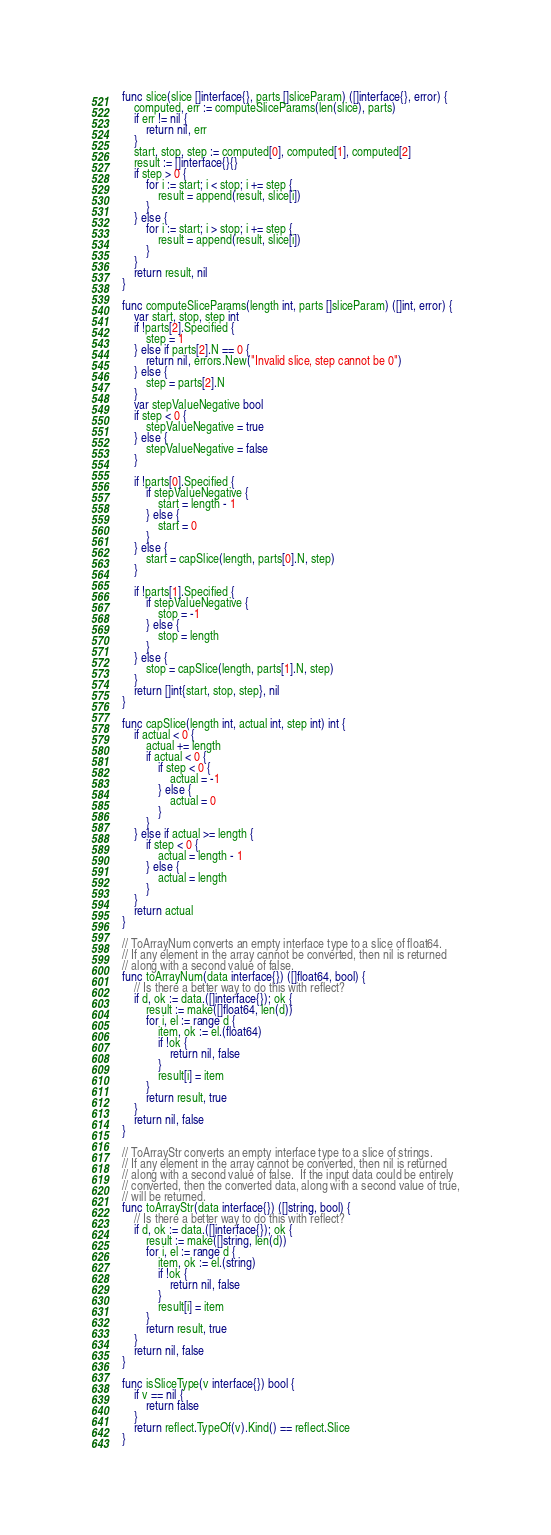<code> <loc_0><loc_0><loc_500><loc_500><_Go_>func slice(slice []interface{}, parts []sliceParam) ([]interface{}, error) {
	computed, err := computeSliceParams(len(slice), parts)
	if err != nil {
		return nil, err
	}
	start, stop, step := computed[0], computed[1], computed[2]
	result := []interface{}{}
	if step > 0 {
		for i := start; i < stop; i += step {
			result = append(result, slice[i])
		}
	} else {
		for i := start; i > stop; i += step {
			result = append(result, slice[i])
		}
	}
	return result, nil
}

func computeSliceParams(length int, parts []sliceParam) ([]int, error) {
	var start, stop, step int
	if !parts[2].Specified {
		step = 1
	} else if parts[2].N == 0 {
		return nil, errors.New("Invalid slice, step cannot be 0")
	} else {
		step = parts[2].N
	}
	var stepValueNegative bool
	if step < 0 {
		stepValueNegative = true
	} else {
		stepValueNegative = false
	}

	if !parts[0].Specified {
		if stepValueNegative {
			start = length - 1
		} else {
			start = 0
		}
	} else {
		start = capSlice(length, parts[0].N, step)
	}

	if !parts[1].Specified {
		if stepValueNegative {
			stop = -1
		} else {
			stop = length
		}
	} else {
		stop = capSlice(length, parts[1].N, step)
	}
	return []int{start, stop, step}, nil
}

func capSlice(length int, actual int, step int) int {
	if actual < 0 {
		actual += length
		if actual < 0 {
			if step < 0 {
				actual = -1
			} else {
				actual = 0
			}
		}
	} else if actual >= length {
		if step < 0 {
			actual = length - 1
		} else {
			actual = length
		}
	}
	return actual
}

// ToArrayNum converts an empty interface type to a slice of float64.
// If any element in the array cannot be converted, then nil is returned
// along with a second value of false.
func toArrayNum(data interface{}) ([]float64, bool) {
	// Is there a better way to do this with reflect?
	if d, ok := data.([]interface{}); ok {
		result := make([]float64, len(d))
		for i, el := range d {
			item, ok := el.(float64)
			if !ok {
				return nil, false
			}
			result[i] = item
		}
		return result, true
	}
	return nil, false
}

// ToArrayStr converts an empty interface type to a slice of strings.
// If any element in the array cannot be converted, then nil is returned
// along with a second value of false.  If the input data could be entirely
// converted, then the converted data, along with a second value of true,
// will be returned.
func toArrayStr(data interface{}) ([]string, bool) {
	// Is there a better way to do this with reflect?
	if d, ok := data.([]interface{}); ok {
		result := make([]string, len(d))
		for i, el := range d {
			item, ok := el.(string)
			if !ok {
				return nil, false
			}
			result[i] = item
		}
		return result, true
	}
	return nil, false
}

func isSliceType(v interface{}) bool {
	if v == nil {
		return false
	}
	return reflect.TypeOf(v).Kind() == reflect.Slice
}
</code> 